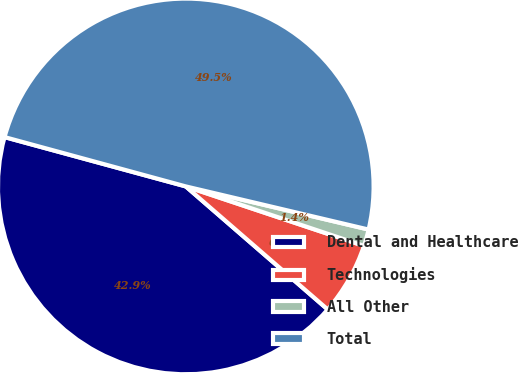<chart> <loc_0><loc_0><loc_500><loc_500><pie_chart><fcel>Dental and Healthcare<fcel>Technologies<fcel>All Other<fcel>Total<nl><fcel>42.86%<fcel>6.24%<fcel>1.44%<fcel>49.46%<nl></chart> 